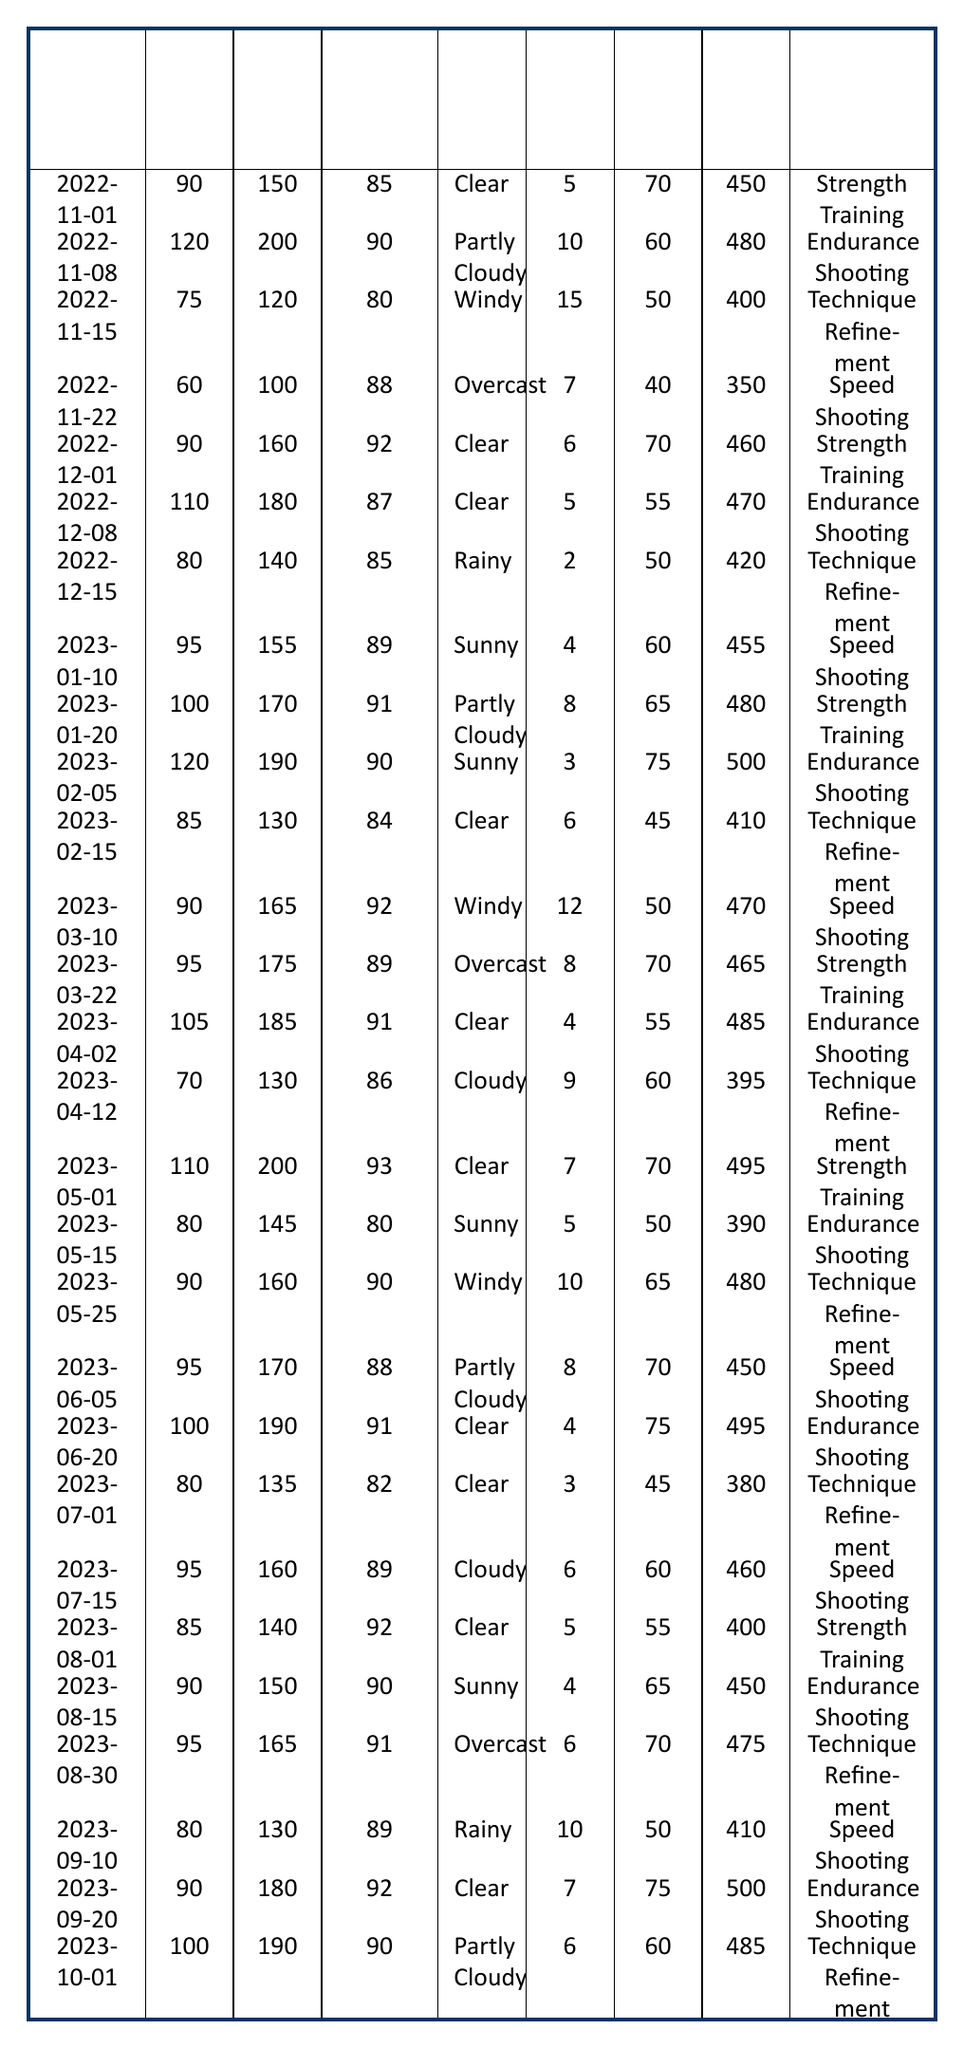What was the maximum score achieved in a training session? Reviewing the table, I find that the highest score listed is 500, which occurred during the session on 2023-02-05 for Endurance Shooting.
Answer: 500 What is the average duration of sessions during the year? The total duration of sessions is calculated by adding all durations (90 + 120 + 75 + 60 + 90 + 110 + 80 + 95 + 100 + 120 + 85 + 90 + 95 + 105 + 70 + 110 + 80 + 90 + 95 + 100 + 80 + 95 + 85 + 90 + 95 + 80 + 90 + 100)/28 = 91.07 approximately.
Answer: 91.07 How many sessions had a goal accuracy percentage of 90 or above? Counting sessions where the goal accuracy percentage is 90 or higher, I see there are 9 such instances: 2022-11-08, 2022-12-01, 2022-12-08, 2023-01-20, 2023-02-05, 2023-03-10, 2023-04-02, 2023-05-01, 2023-09-20.
Answer: 9 Was there a session type that recorded an accuracy below 80%? Checking the table, I find one session type (Endurance Shooting on 2023-05-15) that has a goal accuracy percentage of 80, which is not below. No sessions fall below this threshold.
Answer: No What is the average number of arrows shot per session for technique refinement? The arrows shot for technique refinement sessions include: 120 (2022-11-15), 140 (2022-12-15), 130 (2023-02-15), 130 (2023-04-12), 145 (2023-05-25), 135 (2023-07-01), 165 (2023-08-30), and 130 (2023-09-10); summing these gives 1,065, and dividing by the 8 technique refinement sessions gives 133.125.
Answer: 133.125 How many sessions were held in clear weather conditions? By inspecting the data, I count 11 sessions where the weather was clear: (multiple dates); hence there were 11 clear sessions.
Answer: 11 Which session had the longest duration and what was the session type? Looking at the durations, the longest session was 120 minutes on 2023-02-05 for Endurance Shooting.
Answer: 120 minutes, Endurance Shooting What was the total score accumulated over the sessions? By adding all the scores from each session (450 + 480 + 400 + 350 + 460 + 470 + 420 + 455 + 480 + 500 + 410 + 470 + 465 + 485 + 395 + 495 + 390 + 480 + 450 + 495 + 380 + 460 + 400 + 450 + 475 + 410 + 500 + 485) the total score amounts to 12,140.
Answer: 12140 Did any Endurance Shooting session record a wind speed higher than 6 mph? Reviewing the data, I find two sessions labeled as Endurance Shooting that recorded wind speeds above 6 mph (2022-12-08, 2023-02-05, and 2023-04-02).
Answer: Yes On which date did the first Speed Shooting session occur, and what was its score? The first instance of Speed Shooting appears on 2022-11-22 with a score of 350.
Answer: 2022-11-22, 350 